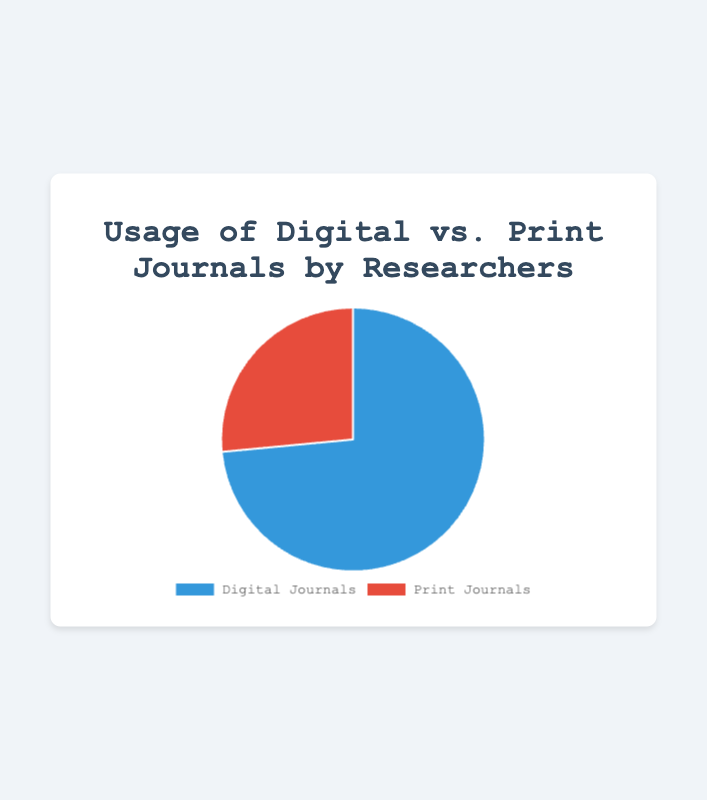What percentage of researchers use Digital Journals? The figure shows the slices for Digital and Print Journals usage. The slice labeled "Digital Journals" is 73.5%.
Answer: 73.5% What type of journal has the higher usage percentage? The figure shows two slices of a pie chart, one for Digital Journals and one for Print Journals. The slice for Digital Journals is 73.5% and the slice for Print Journals is 26.5%. Digital Journals have a higher percentage.
Answer: Digital Journals How much more percentage of researchers use Digital Journals compared to Print Journals? The Digital Journals slice is 73.5%, and Print Journals slice is 26.5%. The difference is calculated by subtracting 26.5% from 73.5%, which is 47%.
Answer: 47% What is the combined percentage use of Digital and Print Journals? The sum of the two data points representing the usage of Digital and Print Journals is 73.5% + 26.5%. The combined usage is 100%.
Answer: 100% Which color represents the usage of Print Journals in the figure? The figure uses two colors to differentiate between the two types of journals. The slice for Print Journals is represented by the red color, as observed from its appearance.
Answer: Red If the number of researchers is 1000, how many researchers use Print Journals? 26.5% of 1000 researchers use Print Journals. To find this number, multiply 1000 by 0.265, which gives 265 researchers.
Answer: 265 Calculate the ratio of Digital Journal users to Print Journal users. The percentage usage for Digital Journals is 73.5% and for Print Journals is 26.5%. The ratio is 73.5 to 26.5, which simplifies to approximately 2.77:1 when divided by their greatest common divisor.
Answer: 2.77:1 What percentage of the pie chart is made up of Print Journal usage? The figure includes a pie chart with two slices. Print Journals account for 26.5% of the pie chart as indicated in the percentage label.
Answer: 26.5% Is the percentage of Print Journals usage less than a third of the total usage? One third of 100% is roughly 33.33%. The usage of Print Journals is 26.5%, which is less than 33.33%.
Answer: Yes 